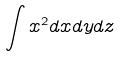Convert formula to latex. <formula><loc_0><loc_0><loc_500><loc_500>\int x ^ { 2 } d x d y d z</formula> 